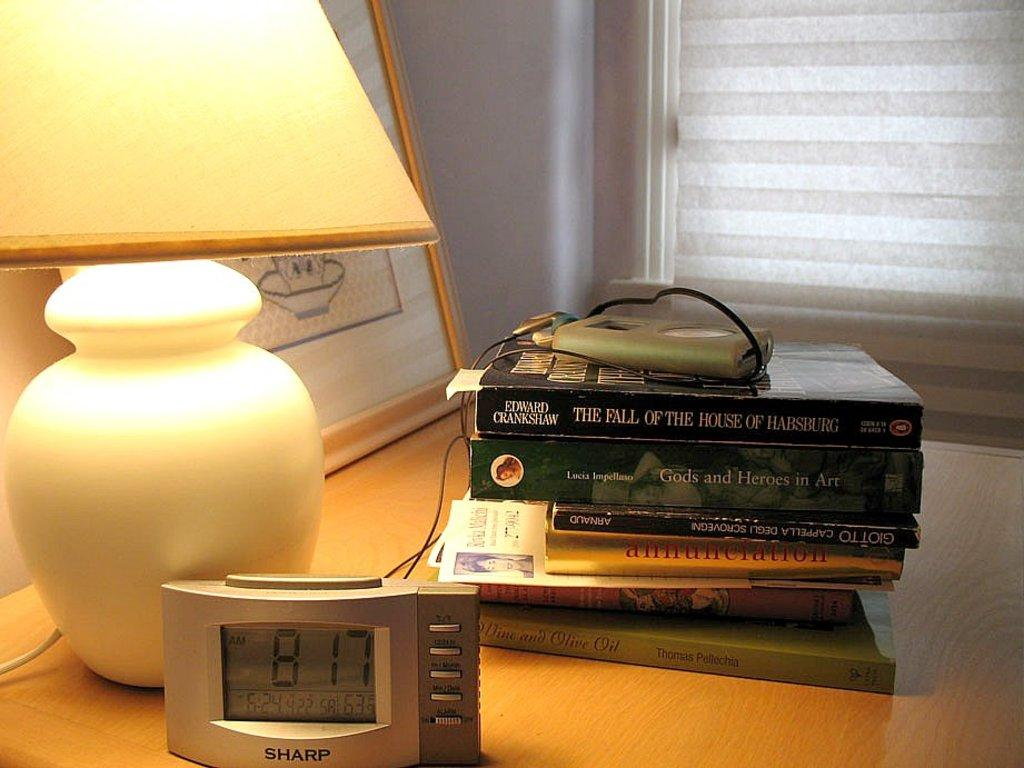<image>
Describe the image concisely. A stack of books and an alarm clock showing the time of 8:17 both sitting on a nightstand. 